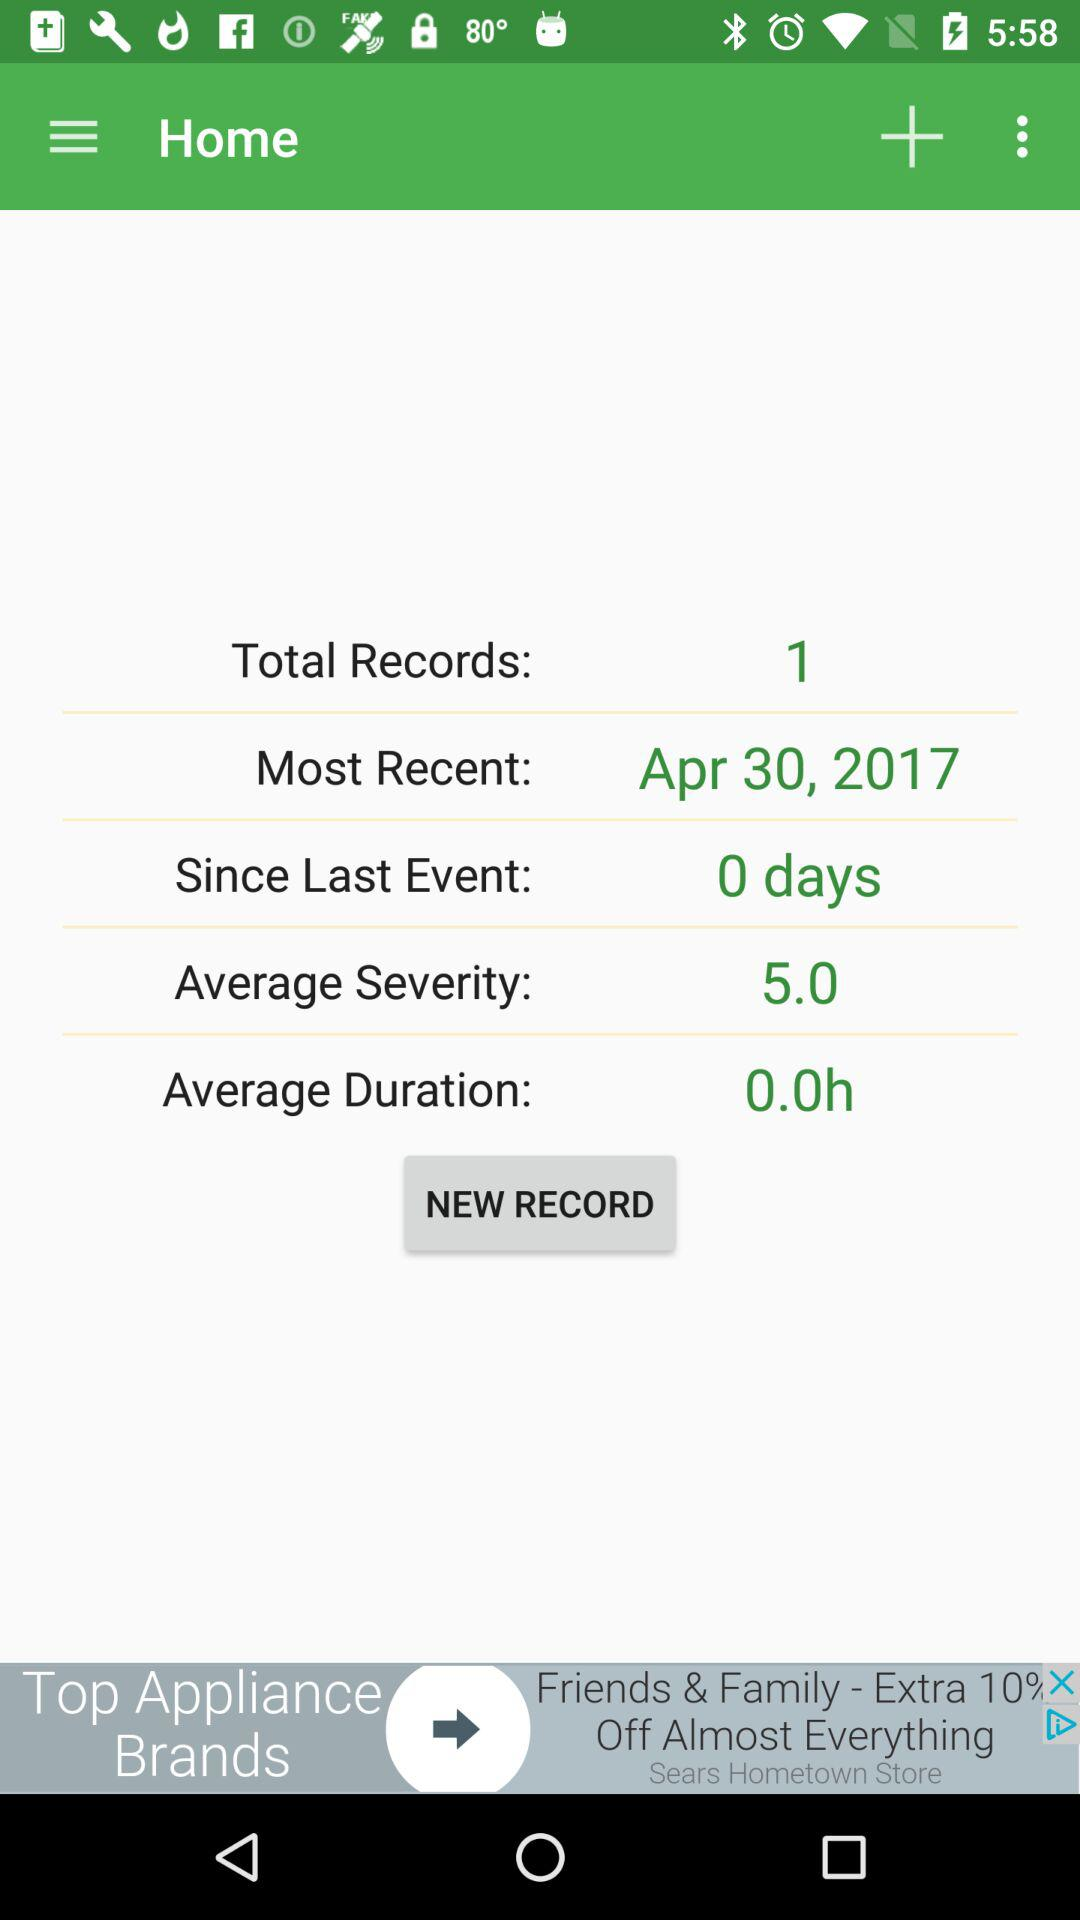How many records are shown there? There is 1 record shown. 